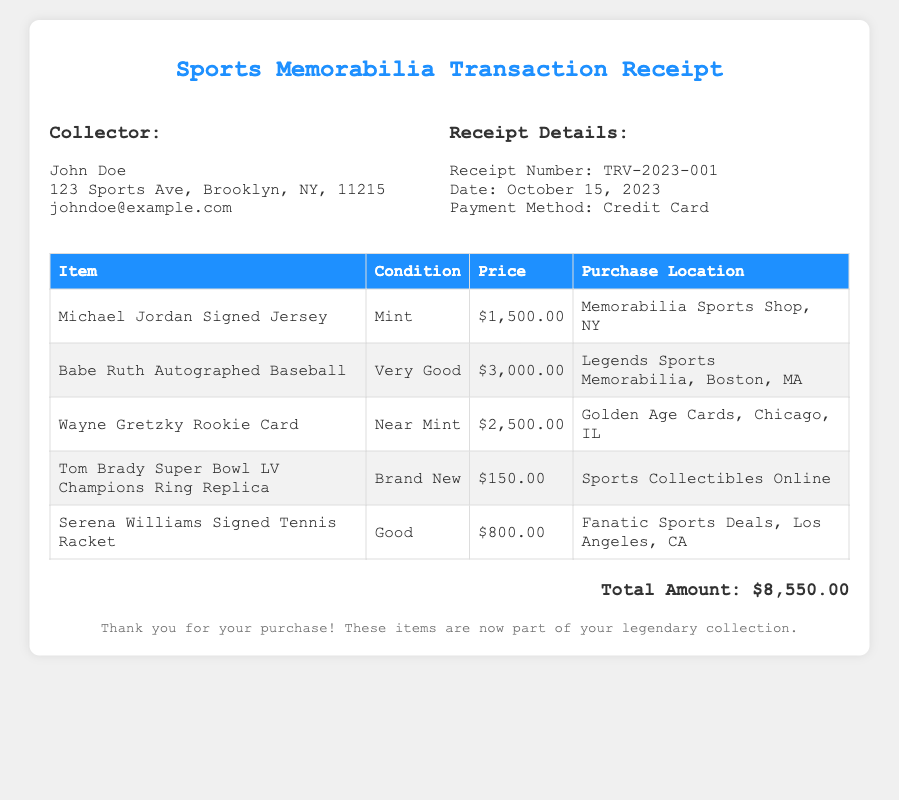What is the name of the collector? The collector's name is provided in the document.
Answer: John Doe What is the receipt number? The document specifies a unique receipt number.
Answer: TRV-2023-001 What is the date of the purchase? The date of the transaction is indicated in the receipt details.
Answer: October 15, 2023 How much did the Babe Ruth autographed baseball cost? The price for that specific item is listed in the table.
Answer: $3,000.00 Which item has the condition listed as "Brand New"? The document provides a condition for each item, indicating its state.
Answer: Tom Brady Super Bowl LV Champions Ring Replica What is the total amount spent on all items? The document sums up all individual item prices to show the total expenditure.
Answer: $8,550.00 Which city is the Legends Sports Memorabilia located? The purchase location details provide the city of the shop.
Answer: Boston How many items were purchased in total? By counting the number of lines in the item table, we can determine the total.
Answer: 5 